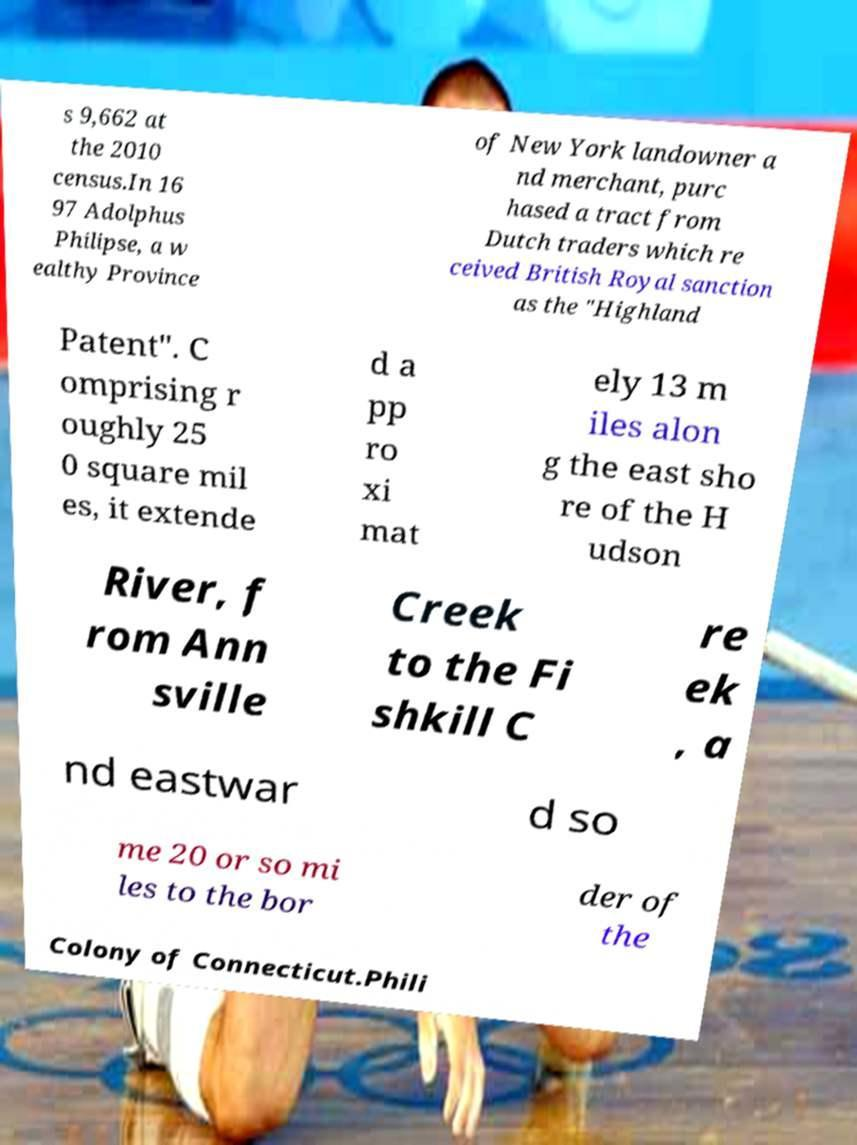Could you extract and type out the text from this image? s 9,662 at the 2010 census.In 16 97 Adolphus Philipse, a w ealthy Province of New York landowner a nd merchant, purc hased a tract from Dutch traders which re ceived British Royal sanction as the "Highland Patent". C omprising r oughly 25 0 square mil es, it extende d a pp ro xi mat ely 13 m iles alon g the east sho re of the H udson River, f rom Ann sville Creek to the Fi shkill C re ek , a nd eastwar d so me 20 or so mi les to the bor der of the Colony of Connecticut.Phili 